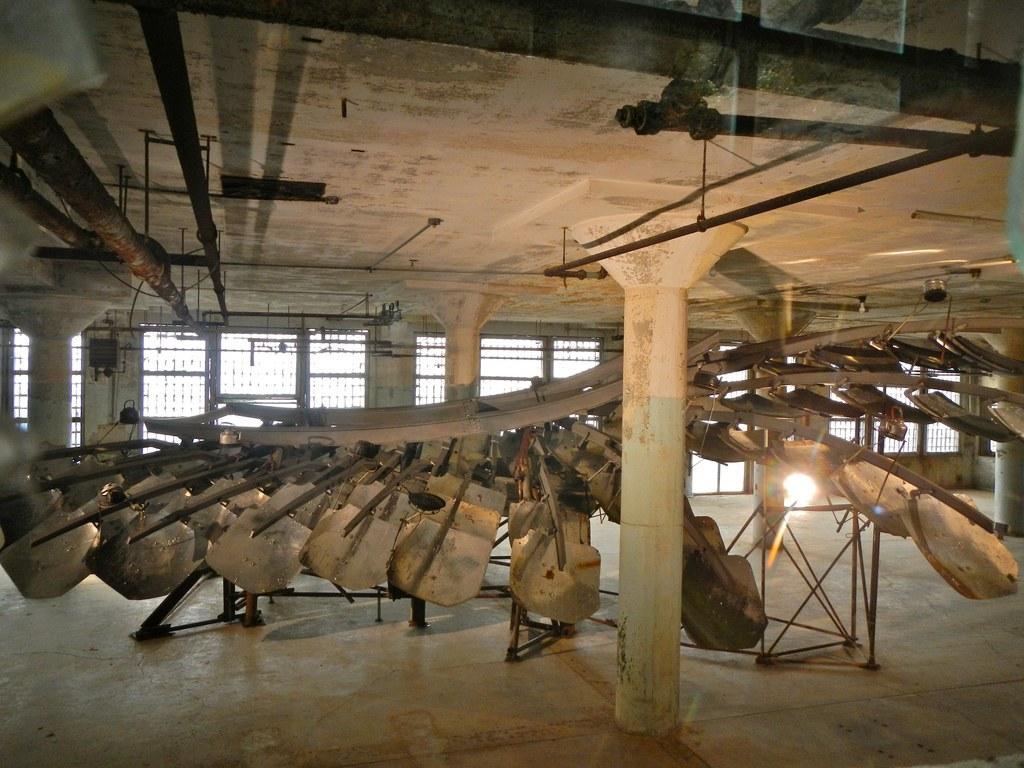Can you describe this image briefly? In this image I see the inside view of a room and I see an object over here which is made of wood and rods and I see the ceiling on which there are many rods and I see the floor and I see number of pillars and I see the light over here. 